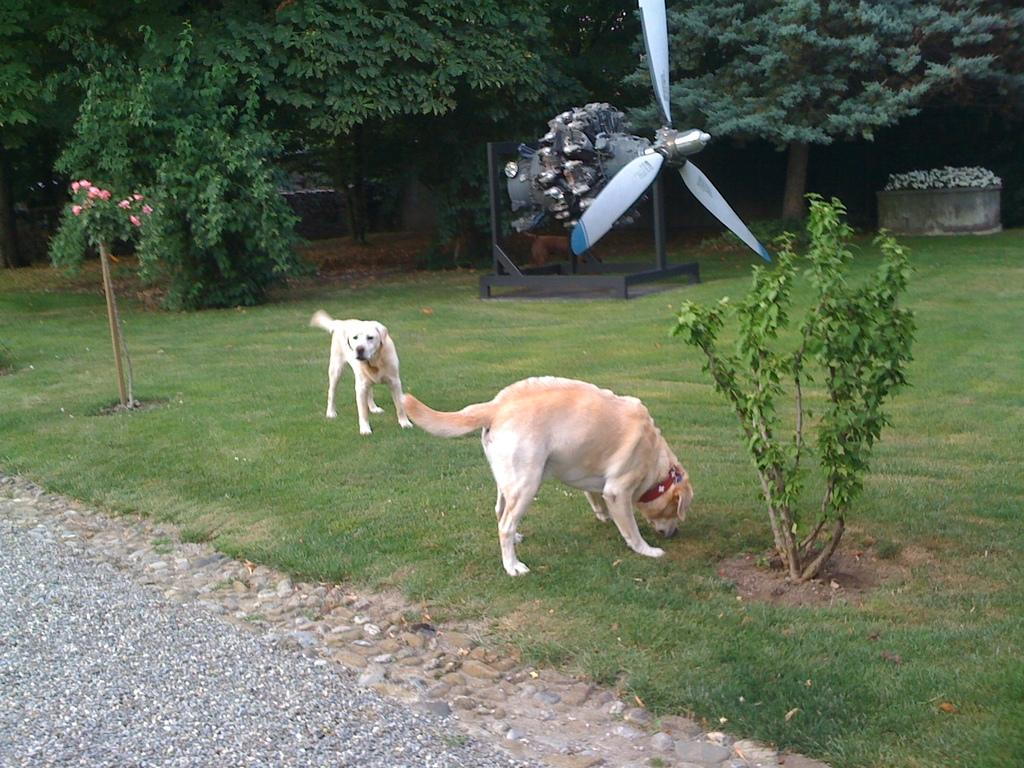How many dogs are in the image? There are two dogs in the image. What is the surface the dogs are standing on? The dogs are standing on the grass. What can be seen in the background of the image? There is a propeller with an engine, trees, and plants in the background of the image. What type of marble is being used to create a sign in the image? There is no marble or sign present in the image. Where can someone sit while observing the dogs in the image? The image does not show any seating or indication of where someone might sit. 